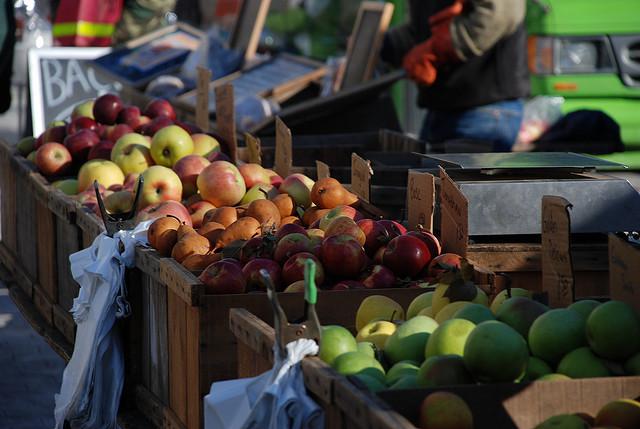How many baskets of fruit are there?
Give a very brief answer. 5. What is the yellow fruit?
Keep it brief. Apple. What food store is this?
Concise answer only. Market. What kind of fruit is pictured?
Keep it brief. Apples. What is the fruit in the front, center of photo?
Write a very short answer. Apple. Is the food in the foreground hot?
Concise answer only. No. What fruit is shown?
Answer briefly. Apples. Are there bananas in this picture?
Quick response, please. No. What are the baskets made out of?
Write a very short answer. Wood. What is being sold?
Answer briefly. Fruit. Are the crates made of plastic?
Write a very short answer. No. What are the green things?
Be succinct. Apples. Are there any flowers in the photo?
Give a very brief answer. No. What fruit if the man reaching for?
Give a very brief answer. Apple. Where are the vegetables located?
Concise answer only. Boxes. What do the signs on the apples indicate?
Quick response, please. Prices. What kind of fruit is in the cart?
Quick response, please. Apples. What material is the price signs made of?
Write a very short answer. Cardboard. Does this fruit stand carry many different kinds of produce?
Keep it brief. No. Is all of this fruit ripe?
Answer briefly. Yes. 